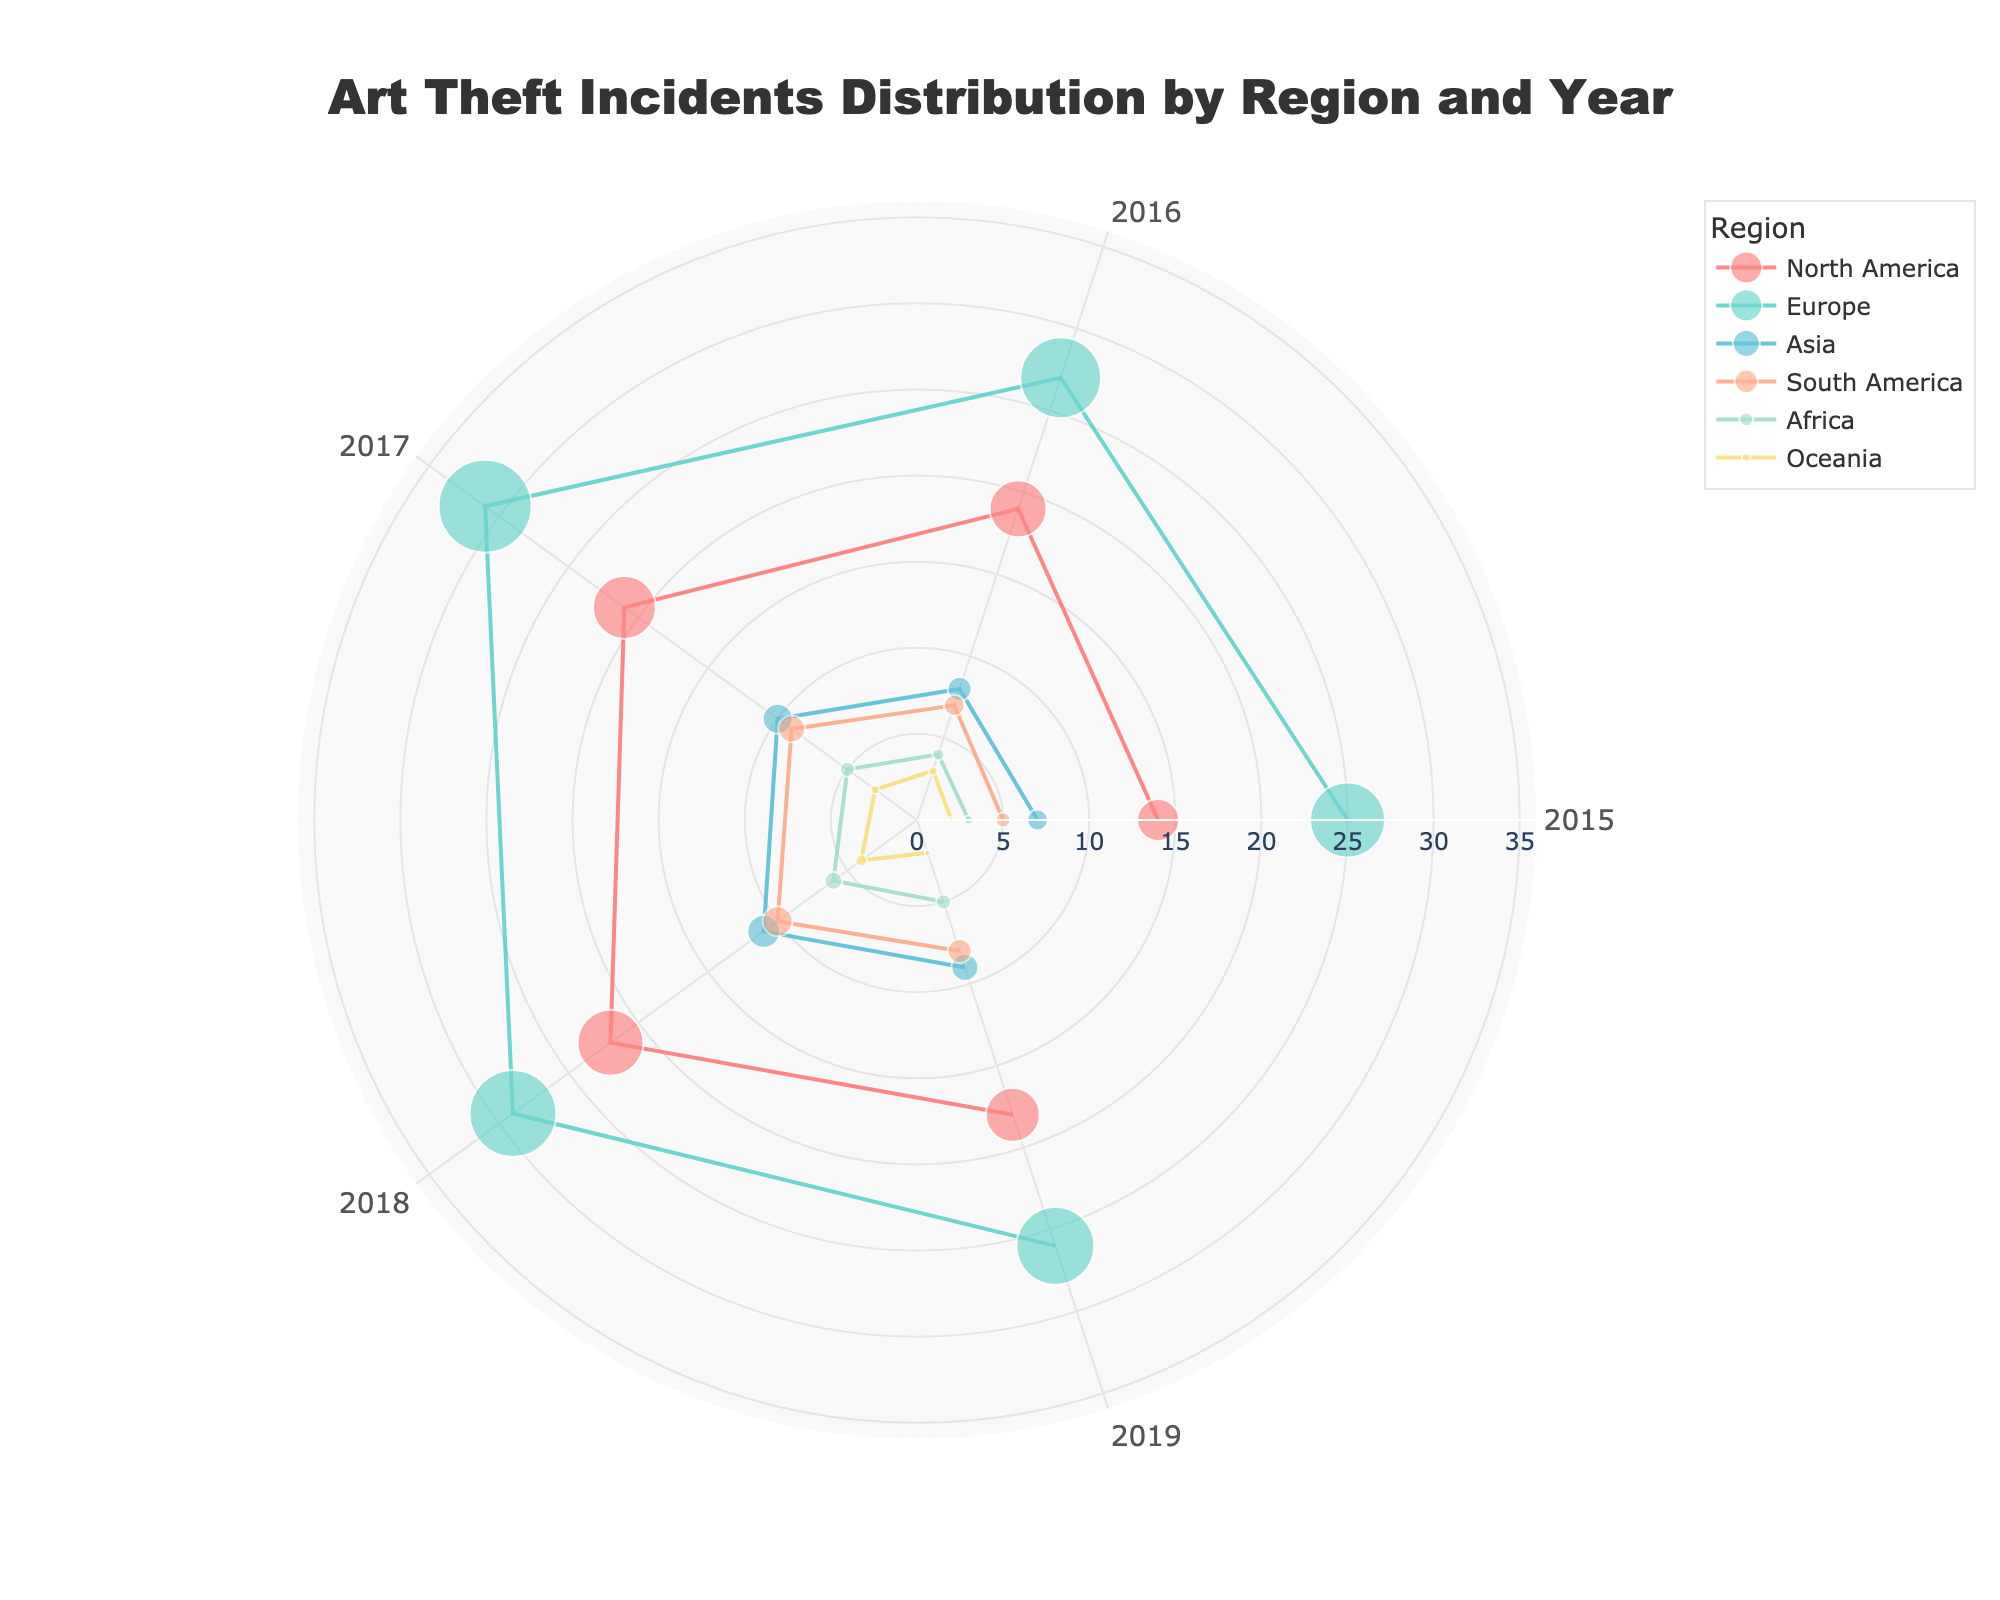What's the title of the figure? The title is displayed at the top center of the figure. You can see it reads "Art Theft Incidents Distribution by Region and Year".
Answer: Art Theft Incidents Distribution by Region and Year How many regions are represented in the scatter plot? Looking at the legend of the figure, which lists the regions, we can see there are six regions represented.
Answer: Six Which region had the highest number of art theft incidents in 2018? From the scatter plot, looking at the '2018' theta axis and highest r values, we see that Europe had the most incidents in 2018.
Answer: Europe What is the range of the radial axis on the polar scatter chart? The radial axis is marked with ticks starting from 0 to 35. This can be observed from the radial lines extending outward from the center of the polar plot.
Answer: 0 to 35 Compare the incidents of art theft in Africa and Oceania for 2017. Which one had more incidents and by how much? From the dots on the '2017' axis, Africa had 5 incidents while Oceania had 3 incidents. The difference is 5 - 3 = 2.
Answer: Africa by 2 What is the color representing Asia in the figure? By referring to the legend, we can see that the color associated with Asia is a blue tone.
Answer: Blue Find the total number of art theft incidents in North America from 2015 to 2019. Sum the incidents for North America: 14 (2015) + 19 (2016) + 21 (2017) + 22 (2018) + 18 (2019) = 94.
Answer: 94 Which year saw the highest number of art theft incidents in Europe? By checking the points along the 'Europe' line, we notice the highest r value is for the year 2017 with 31 incidents.
Answer: 2017 Identify the region with the consistently lowest number of art theft incidents from 2015 to 2019. By comparing the lowest values on the radial axis for all regions, we see that Oceania consistently has the lowest number of incidents.
Answer: Oceania 